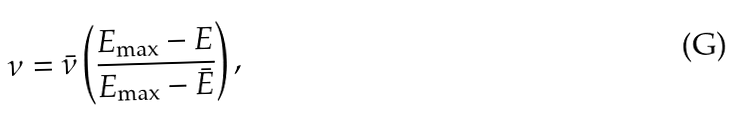<formula> <loc_0><loc_0><loc_500><loc_500>\nu = \bar { \nu } \left ( \frac { E _ { \max } - E } { E _ { \max } - \bar { E } } \right ) ,</formula> 